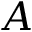<formula> <loc_0><loc_0><loc_500><loc_500>A</formula> 